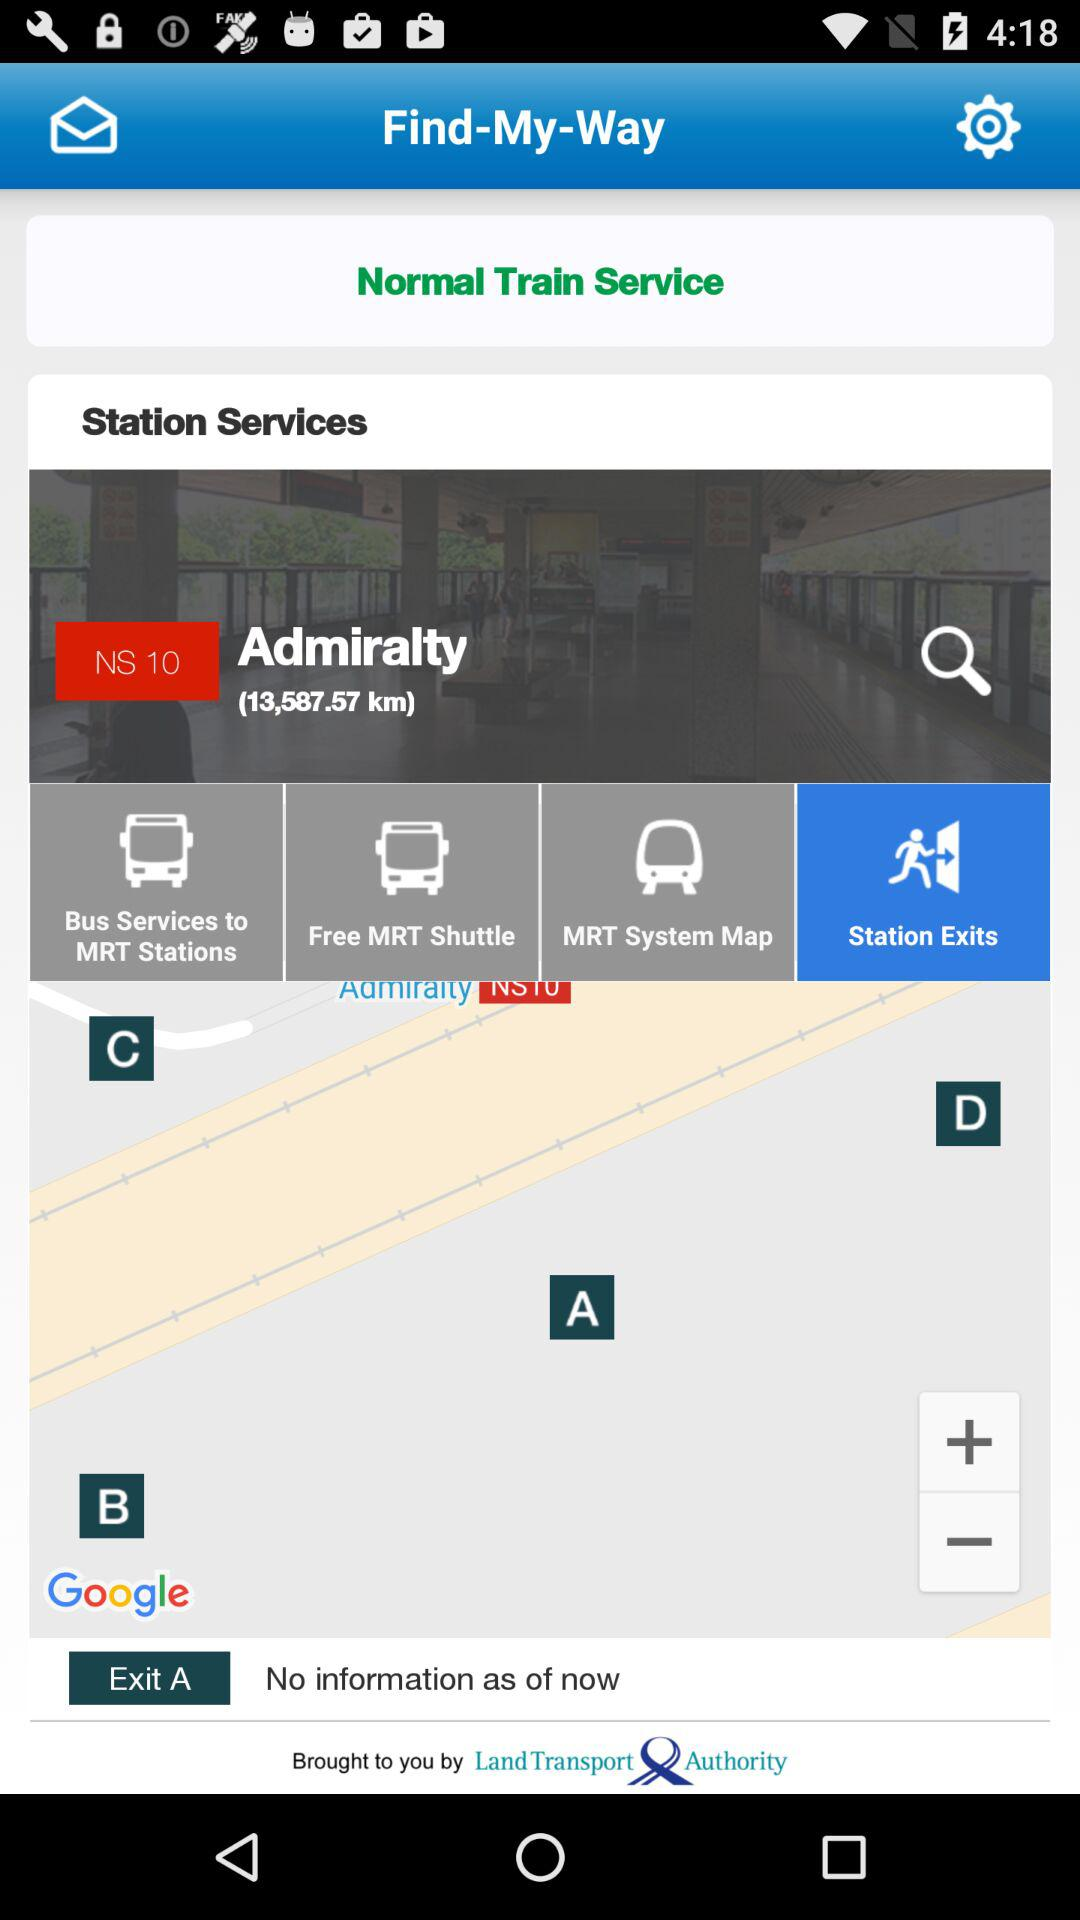By whom is it brought to you? It is brought to you by the "Land Transport Authority". 